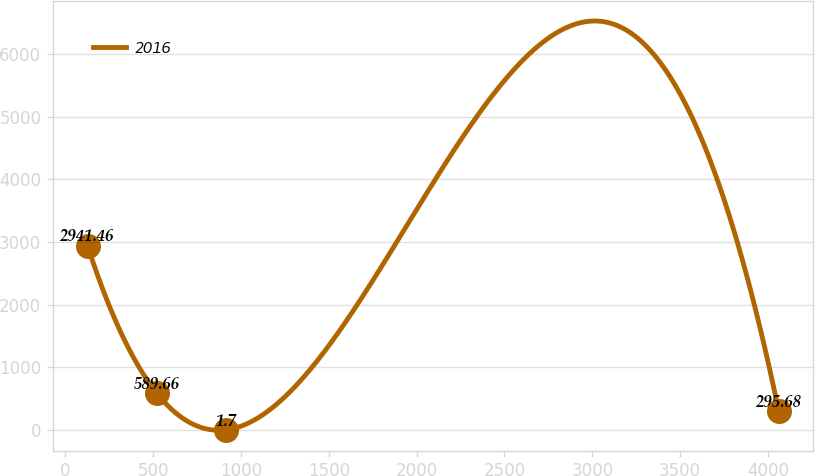Convert chart to OTSL. <chart><loc_0><loc_0><loc_500><loc_500><line_chart><ecel><fcel>2016<nl><fcel>125.59<fcel>2941.46<nl><fcel>519.28<fcel>589.66<nl><fcel>912.97<fcel>1.7<nl><fcel>4062.5<fcel>295.68<nl></chart> 